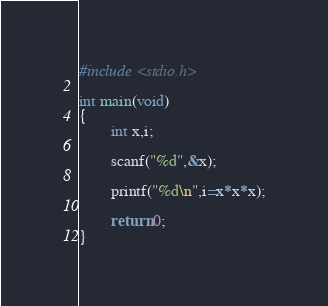<code> <loc_0><loc_0><loc_500><loc_500><_C_>#include <stdio.h>

int main(void)
{
        int x,i;

        scanf("%d",&x);

        printf("%d\n",i=x*x*x);

        return 0;
}</code> 